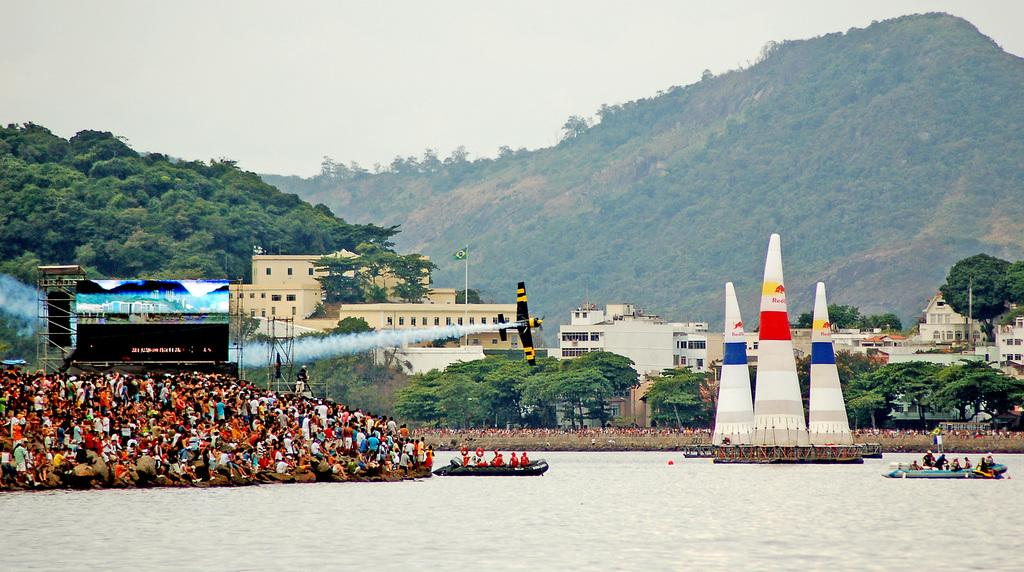What is the main feature in the center of the image? There is sky in the center of the image. What type of natural elements can be seen in the image? There are trees in the image. What type of man-made structures are present in the image? There are buildings in the image. What is the source of the smoke in the image? The source of the smoke is not specified in the image. What type of vehicle is present in the image? There is an airplane in the image. What type of geographical feature is present in the image? There is a hill in the image. What type of technology is present in the image? There is a screen in the image. What type of watercraft can be seen in the image? There are boats on the water in the image. Are there any people visible in the image? Yes, there are people in the image. What other objects can be seen in the image? There are other objects in the image, but their specific details are not mentioned. What type of cake is being served at the camp in the image? There is no cake or camp present in the image. What type of plants are growing near the people in the image? The specific type of plants is not mentioned in the image. 